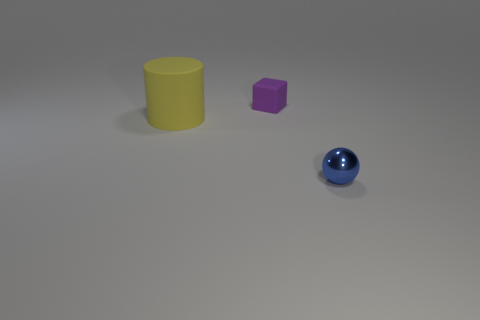Add 3 big blue things. How many objects exist? 6 Subtract all spheres. How many objects are left? 2 Add 2 large green metal balls. How many large green metal balls exist? 2 Subtract 0 green blocks. How many objects are left? 3 Subtract all large gray metallic spheres. Subtract all small matte cubes. How many objects are left? 2 Add 1 yellow things. How many yellow things are left? 2 